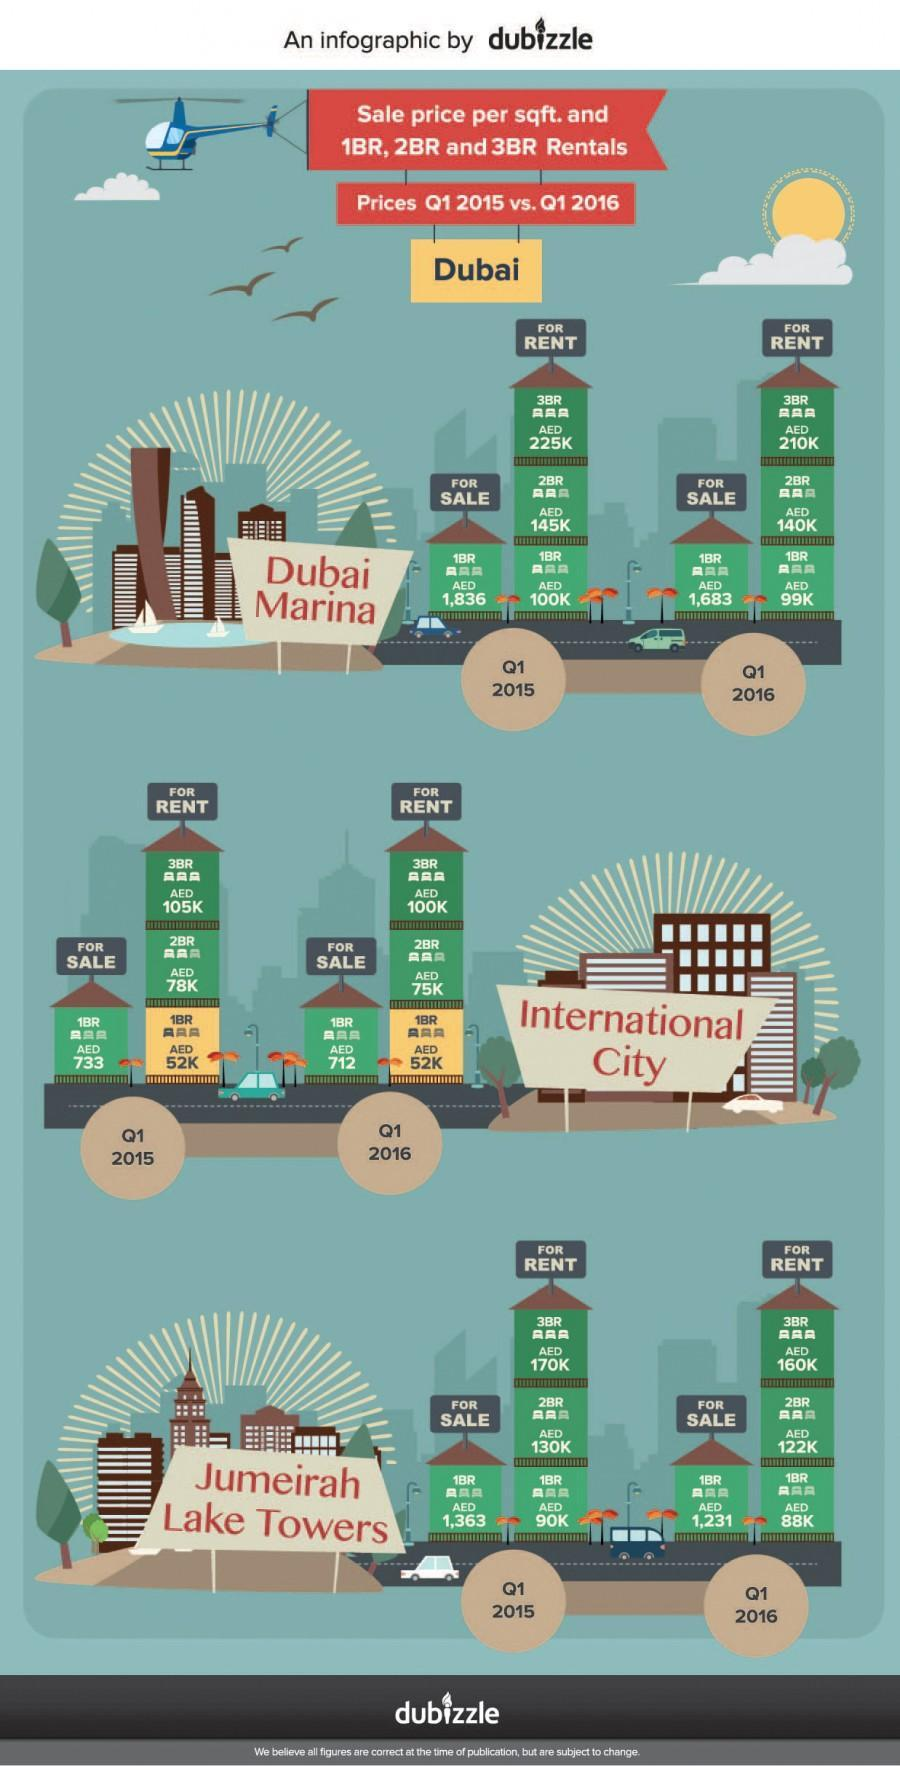What is the Rental rate (AED) of 3 Bed Room flat in the first quarter of 2016 in Dubai International City?
Answer the question with a short phrase. 100K How much is the rent (AED) of 1 and 2 Bed Room flat taken together in Jumeirah Lake towers for the first quarter of 2016? 210 What is the selling price (AED) of 1 Bed Room flat in the first quarter of 2016 in Dubai International City? 712 What is the Rental rate (AED) of 1 Bed Room flat in the first quarter of 2015 in Dubai International City? 52K What is the Rental rate (AED) of 3 Bed Room flat in the first quarter of 2016 in Dubai Marina? 210K What is the Rental rate (AED) of 1 Bed Room flat in the first quarter of 2016 in Dubai Marina? 99K What is the Rental rate (AED) of 2 Bed Room flat in the first quarter of 2016 in Dubai Marina? 145K What is the Rental rate (AED) of 1 Bed Room flat in the first quarter of 2016 in Dubai International City? 52K What is the Rental rate (AED) of 2 Bed Room flat in the first quarter of 2016 in Dubai International City? 75K How much is the rent (AED) of 1 and 2 Bed Room flat taken together in Jumeirah Lake towers for the first quarter of 2015? 220 